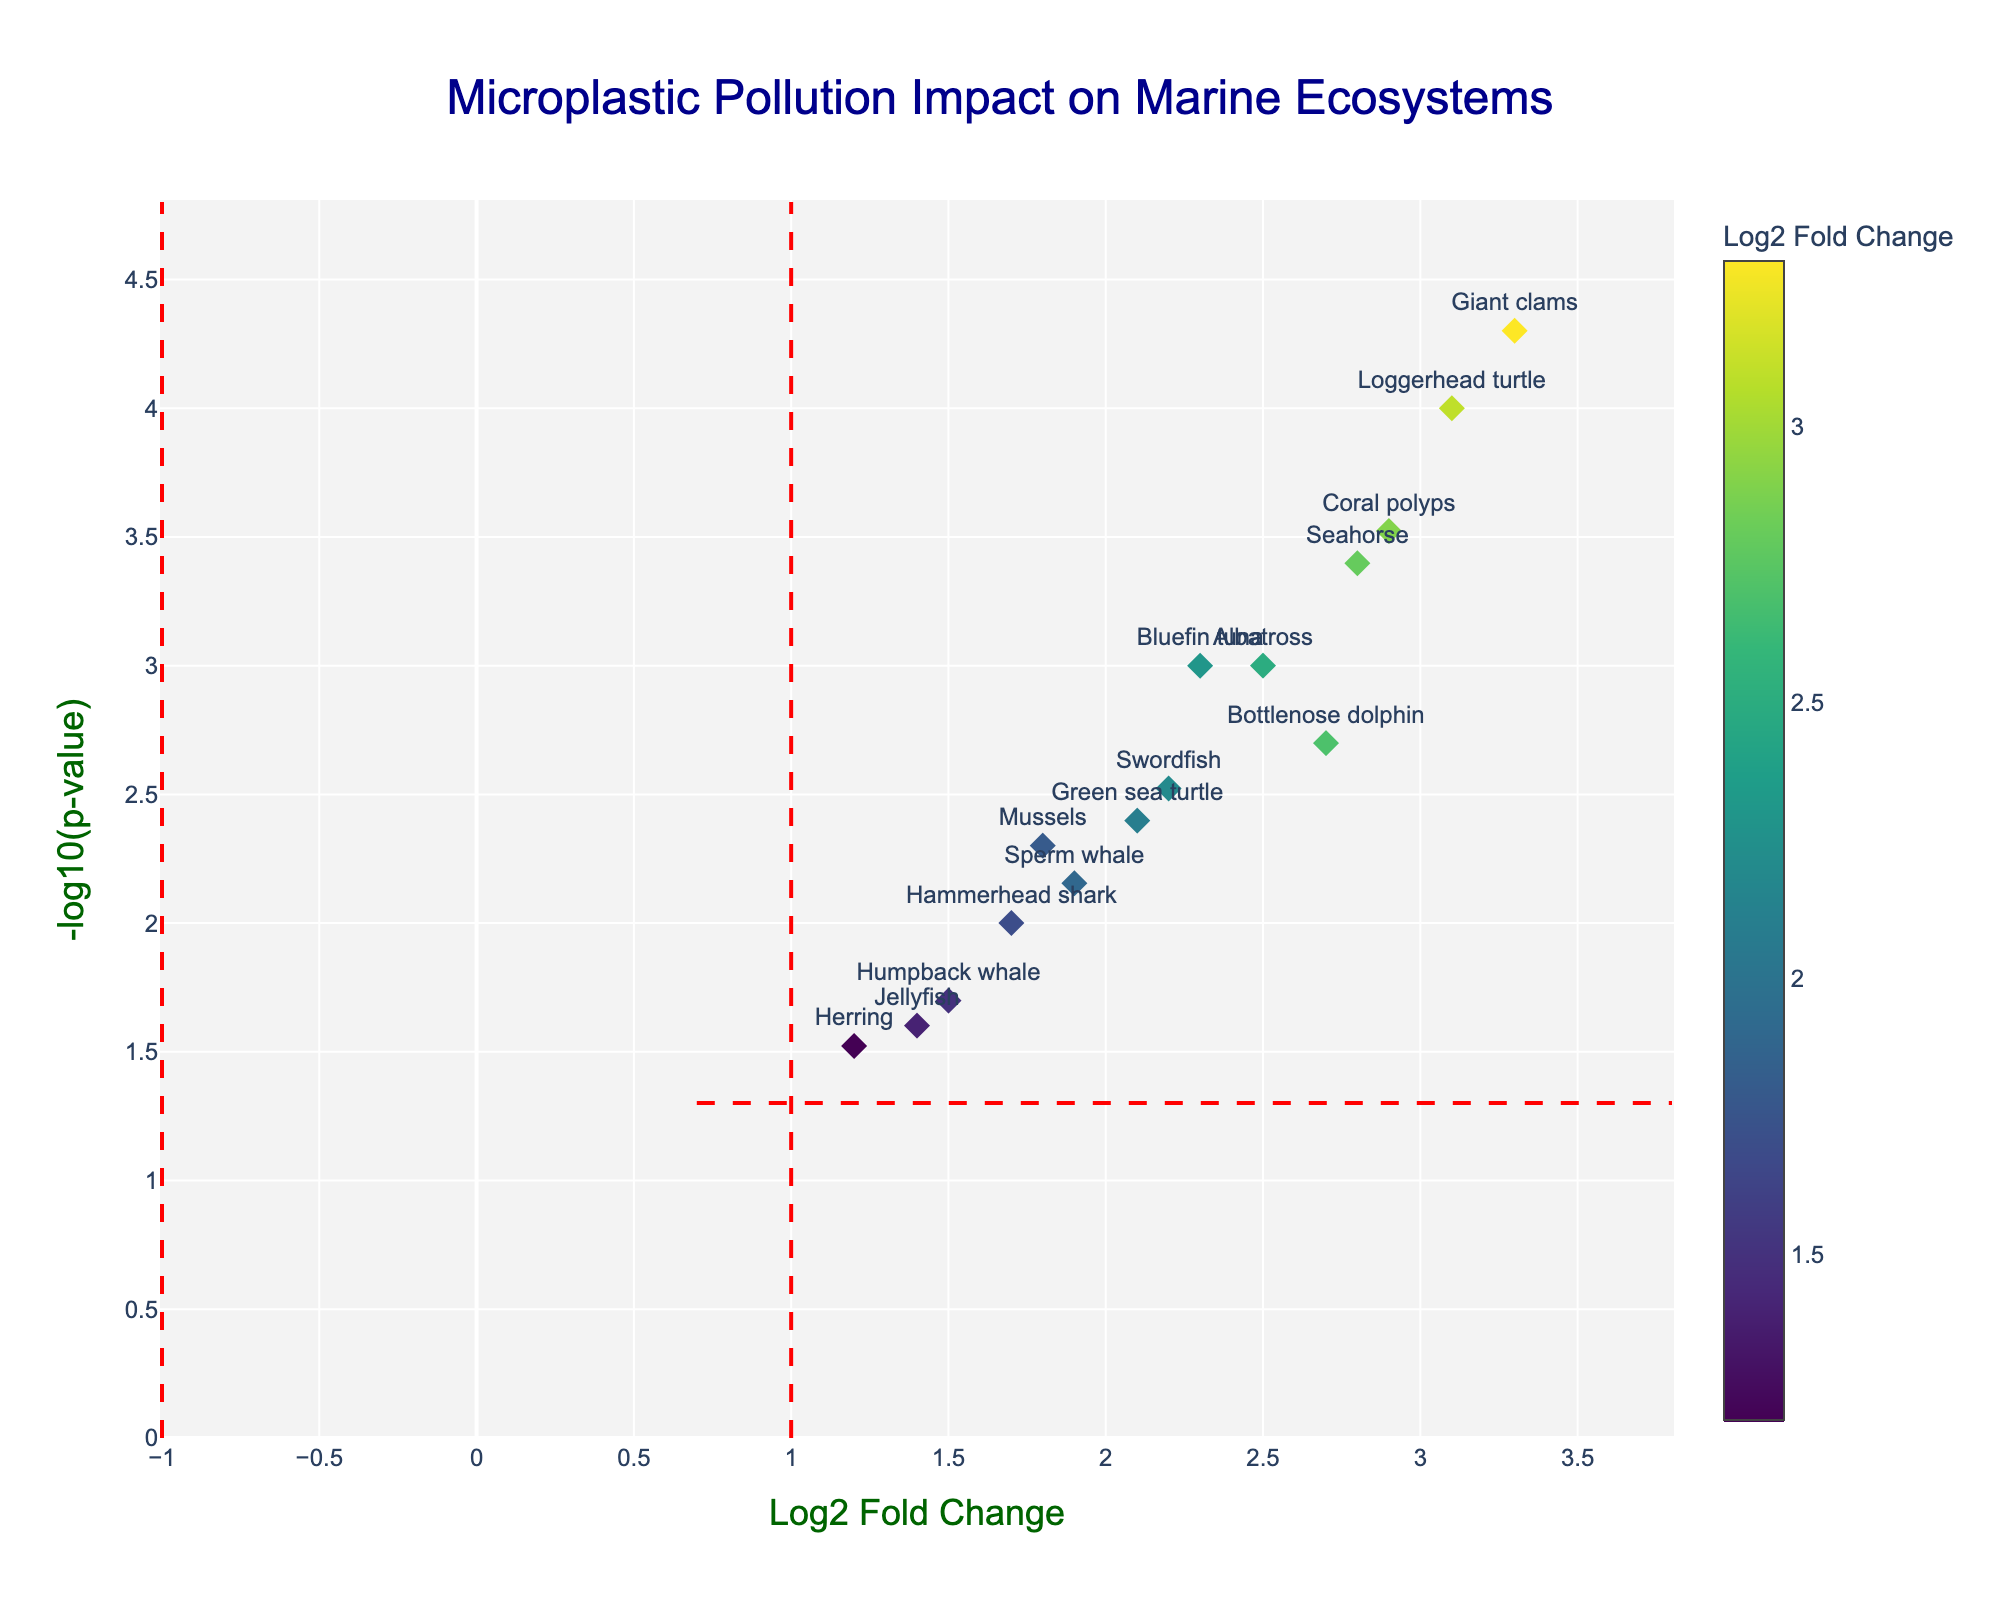What is the title of the figure? The title is displayed at the top center of the figure.
Answer: Microplastic Pollution Impact on Marine Ecosystems How many different organisms are represented in the figure? Each point in the plot corresponds to a different organism, with 14 organisms total in the dataset.
Answer: 14 Which organism has the highest -log10(p-value)? The -log10(p-value) axis indicates the statistical significance of the results. The point highest on this axis represents the organism with the highest value.
Answer: Giant clams Which organism has the lowest Log2 Fold Change? The Log2 Fold Change axis represents the change in contamination levels. The point furthest to the left of the axis represents the lowest fold change.
Answer: Herring What is the general color trend for the points with the largest Log2 Fold Change values? The color bar indicates that higher Log2 Fold Change values are shown in lighter colors.
Answer: Lighter colors What is the Log2 Fold Change of the organism located at the top right of the figure? The top right represents both high Log2 Fold Change and high -log10(p-value). The organism at this position is Giant clams.
Answer: 3.3 Between Bluefin tuna and Bottlenose dolphin, which has a more significant p-value? More significant p-values are represented by higher -log10(p-value) values. Comparing the heights of the points for Bluefin tuna and Bottlenose dolphin.
Answer: Bluefin tuna Which region's data point indicates the least statistically significant contamination? The least statistically significant point will be the lowest on the -log10(p-value) axis.
Answer: Black Sea (Jellyfish) What fold change threshold is indicated by the vertical dashed lines? The vertical dashed lines divide the plot into regions of significant and non-significant fold changes. Checking the x-axis positions reveals they are at -1 and 1.
Answer: 1 and -1 What is the p-value threshold indicated by the horizontal dashed line? The horizontal dashed line separates points of significant p-values from non-significant ones, typically at a p-value of 0.05. Calculating -log10(0.05).
Answer: 1.3010 